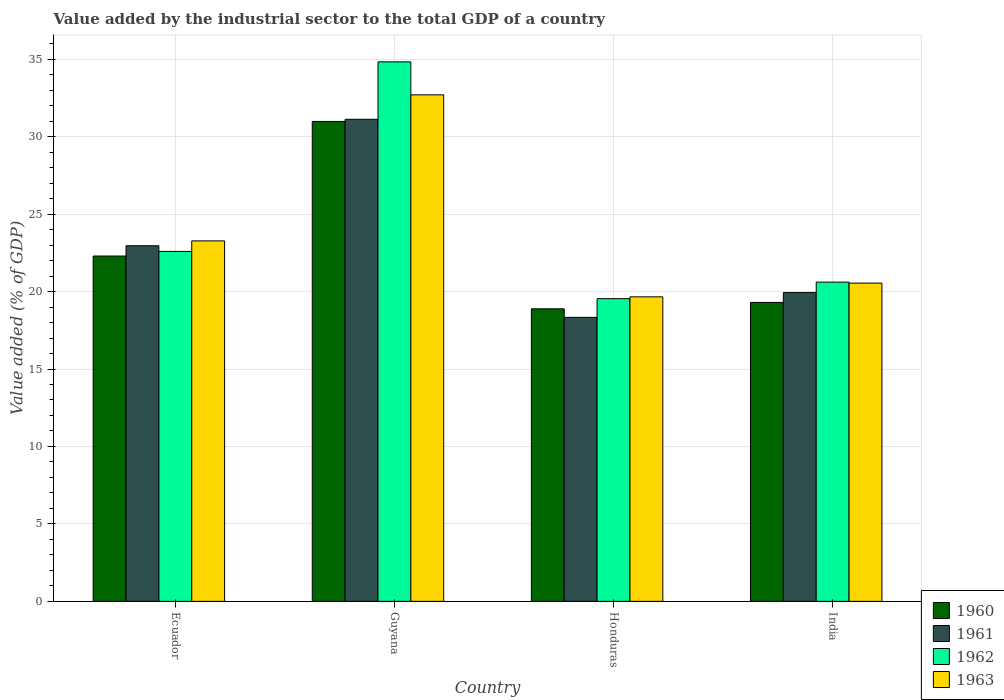How many different coloured bars are there?
Your answer should be very brief. 4. How many groups of bars are there?
Ensure brevity in your answer.  4. How many bars are there on the 3rd tick from the right?
Your answer should be compact. 4. What is the label of the 4th group of bars from the left?
Offer a very short reply. India. In how many cases, is the number of bars for a given country not equal to the number of legend labels?
Make the answer very short. 0. What is the value added by the industrial sector to the total GDP in 1963 in India?
Give a very brief answer. 20.54. Across all countries, what is the maximum value added by the industrial sector to the total GDP in 1960?
Provide a succinct answer. 30.98. Across all countries, what is the minimum value added by the industrial sector to the total GDP in 1961?
Provide a short and direct response. 18.33. In which country was the value added by the industrial sector to the total GDP in 1962 maximum?
Offer a very short reply. Guyana. In which country was the value added by the industrial sector to the total GDP in 1960 minimum?
Keep it short and to the point. Honduras. What is the total value added by the industrial sector to the total GDP in 1961 in the graph?
Your answer should be compact. 92.35. What is the difference between the value added by the industrial sector to the total GDP in 1962 in Ecuador and that in Guyana?
Provide a short and direct response. -12.24. What is the difference between the value added by the industrial sector to the total GDP in 1962 in India and the value added by the industrial sector to the total GDP in 1963 in Guyana?
Your answer should be very brief. -12.09. What is the average value added by the industrial sector to the total GDP in 1961 per country?
Provide a short and direct response. 23.09. What is the difference between the value added by the industrial sector to the total GDP of/in 1963 and value added by the industrial sector to the total GDP of/in 1962 in Guyana?
Provide a short and direct response. -2.13. In how many countries, is the value added by the industrial sector to the total GDP in 1962 greater than 31 %?
Offer a very short reply. 1. What is the ratio of the value added by the industrial sector to the total GDP in 1963 in Honduras to that in India?
Give a very brief answer. 0.96. Is the value added by the industrial sector to the total GDP in 1960 in Guyana less than that in India?
Your answer should be very brief. No. Is the difference between the value added by the industrial sector to the total GDP in 1963 in Guyana and India greater than the difference between the value added by the industrial sector to the total GDP in 1962 in Guyana and India?
Offer a very short reply. No. What is the difference between the highest and the second highest value added by the industrial sector to the total GDP in 1962?
Your answer should be very brief. 14.22. What is the difference between the highest and the lowest value added by the industrial sector to the total GDP in 1960?
Offer a terse response. 12.1. Is the sum of the value added by the industrial sector to the total GDP in 1962 in Ecuador and Honduras greater than the maximum value added by the industrial sector to the total GDP in 1963 across all countries?
Provide a short and direct response. Yes. What does the 1st bar from the right in Ecuador represents?
Provide a succinct answer. 1963. Is it the case that in every country, the sum of the value added by the industrial sector to the total GDP in 1960 and value added by the industrial sector to the total GDP in 1962 is greater than the value added by the industrial sector to the total GDP in 1961?
Keep it short and to the point. Yes. How many countries are there in the graph?
Your response must be concise. 4. What is the difference between two consecutive major ticks on the Y-axis?
Provide a short and direct response. 5. Are the values on the major ticks of Y-axis written in scientific E-notation?
Your answer should be very brief. No. Does the graph contain any zero values?
Your answer should be very brief. No. How many legend labels are there?
Provide a short and direct response. 4. What is the title of the graph?
Give a very brief answer. Value added by the industrial sector to the total GDP of a country. What is the label or title of the X-axis?
Keep it short and to the point. Country. What is the label or title of the Y-axis?
Keep it short and to the point. Value added (% of GDP). What is the Value added (% of GDP) of 1960 in Ecuador?
Ensure brevity in your answer.  22.29. What is the Value added (% of GDP) of 1961 in Ecuador?
Keep it short and to the point. 22.96. What is the Value added (% of GDP) of 1962 in Ecuador?
Provide a succinct answer. 22.59. What is the Value added (% of GDP) of 1963 in Ecuador?
Make the answer very short. 23.27. What is the Value added (% of GDP) of 1960 in Guyana?
Keep it short and to the point. 30.98. What is the Value added (% of GDP) in 1961 in Guyana?
Ensure brevity in your answer.  31.12. What is the Value added (% of GDP) in 1962 in Guyana?
Provide a succinct answer. 34.83. What is the Value added (% of GDP) of 1963 in Guyana?
Offer a terse response. 32.7. What is the Value added (% of GDP) of 1960 in Honduras?
Your answer should be compact. 18.89. What is the Value added (% of GDP) of 1961 in Honduras?
Provide a succinct answer. 18.33. What is the Value added (% of GDP) in 1962 in Honduras?
Your response must be concise. 19.54. What is the Value added (% of GDP) of 1963 in Honduras?
Your answer should be very brief. 19.66. What is the Value added (% of GDP) of 1960 in India?
Offer a very short reply. 19.3. What is the Value added (% of GDP) of 1961 in India?
Provide a succinct answer. 19.93. What is the Value added (% of GDP) in 1962 in India?
Your answer should be very brief. 20.61. What is the Value added (% of GDP) in 1963 in India?
Your answer should be compact. 20.54. Across all countries, what is the maximum Value added (% of GDP) of 1960?
Offer a very short reply. 30.98. Across all countries, what is the maximum Value added (% of GDP) of 1961?
Your response must be concise. 31.12. Across all countries, what is the maximum Value added (% of GDP) in 1962?
Your answer should be very brief. 34.83. Across all countries, what is the maximum Value added (% of GDP) of 1963?
Provide a short and direct response. 32.7. Across all countries, what is the minimum Value added (% of GDP) of 1960?
Make the answer very short. 18.89. Across all countries, what is the minimum Value added (% of GDP) in 1961?
Your answer should be very brief. 18.33. Across all countries, what is the minimum Value added (% of GDP) of 1962?
Ensure brevity in your answer.  19.54. Across all countries, what is the minimum Value added (% of GDP) of 1963?
Keep it short and to the point. 19.66. What is the total Value added (% of GDP) in 1960 in the graph?
Offer a terse response. 91.46. What is the total Value added (% of GDP) of 1961 in the graph?
Ensure brevity in your answer.  92.35. What is the total Value added (% of GDP) in 1962 in the graph?
Provide a short and direct response. 97.57. What is the total Value added (% of GDP) in 1963 in the graph?
Provide a succinct answer. 96.17. What is the difference between the Value added (% of GDP) of 1960 in Ecuador and that in Guyana?
Your answer should be very brief. -8.69. What is the difference between the Value added (% of GDP) of 1961 in Ecuador and that in Guyana?
Your response must be concise. -8.17. What is the difference between the Value added (% of GDP) of 1962 in Ecuador and that in Guyana?
Give a very brief answer. -12.24. What is the difference between the Value added (% of GDP) of 1963 in Ecuador and that in Guyana?
Give a very brief answer. -9.43. What is the difference between the Value added (% of GDP) in 1960 in Ecuador and that in Honduras?
Offer a very short reply. 3.41. What is the difference between the Value added (% of GDP) of 1961 in Ecuador and that in Honduras?
Provide a succinct answer. 4.62. What is the difference between the Value added (% of GDP) in 1962 in Ecuador and that in Honduras?
Your answer should be compact. 3.05. What is the difference between the Value added (% of GDP) of 1963 in Ecuador and that in Honduras?
Your answer should be compact. 3.61. What is the difference between the Value added (% of GDP) of 1960 in Ecuador and that in India?
Give a very brief answer. 2.99. What is the difference between the Value added (% of GDP) of 1961 in Ecuador and that in India?
Give a very brief answer. 3.02. What is the difference between the Value added (% of GDP) in 1962 in Ecuador and that in India?
Offer a terse response. 1.98. What is the difference between the Value added (% of GDP) of 1963 in Ecuador and that in India?
Offer a very short reply. 2.73. What is the difference between the Value added (% of GDP) of 1960 in Guyana and that in Honduras?
Offer a very short reply. 12.1. What is the difference between the Value added (% of GDP) of 1961 in Guyana and that in Honduras?
Your answer should be very brief. 12.79. What is the difference between the Value added (% of GDP) in 1962 in Guyana and that in Honduras?
Make the answer very short. 15.29. What is the difference between the Value added (% of GDP) of 1963 in Guyana and that in Honduras?
Your response must be concise. 13.04. What is the difference between the Value added (% of GDP) of 1960 in Guyana and that in India?
Give a very brief answer. 11.68. What is the difference between the Value added (% of GDP) of 1961 in Guyana and that in India?
Your answer should be compact. 11.19. What is the difference between the Value added (% of GDP) of 1962 in Guyana and that in India?
Make the answer very short. 14.22. What is the difference between the Value added (% of GDP) of 1963 in Guyana and that in India?
Keep it short and to the point. 12.15. What is the difference between the Value added (% of GDP) of 1960 in Honduras and that in India?
Provide a short and direct response. -0.41. What is the difference between the Value added (% of GDP) in 1961 in Honduras and that in India?
Offer a very short reply. -1.6. What is the difference between the Value added (% of GDP) of 1962 in Honduras and that in India?
Offer a terse response. -1.07. What is the difference between the Value added (% of GDP) in 1963 in Honduras and that in India?
Make the answer very short. -0.88. What is the difference between the Value added (% of GDP) in 1960 in Ecuador and the Value added (% of GDP) in 1961 in Guyana?
Make the answer very short. -8.83. What is the difference between the Value added (% of GDP) of 1960 in Ecuador and the Value added (% of GDP) of 1962 in Guyana?
Keep it short and to the point. -12.54. What is the difference between the Value added (% of GDP) in 1960 in Ecuador and the Value added (% of GDP) in 1963 in Guyana?
Offer a terse response. -10.4. What is the difference between the Value added (% of GDP) in 1961 in Ecuador and the Value added (% of GDP) in 1962 in Guyana?
Provide a short and direct response. -11.87. What is the difference between the Value added (% of GDP) of 1961 in Ecuador and the Value added (% of GDP) of 1963 in Guyana?
Give a very brief answer. -9.74. What is the difference between the Value added (% of GDP) in 1962 in Ecuador and the Value added (% of GDP) in 1963 in Guyana?
Offer a very short reply. -10.11. What is the difference between the Value added (% of GDP) of 1960 in Ecuador and the Value added (% of GDP) of 1961 in Honduras?
Give a very brief answer. 3.96. What is the difference between the Value added (% of GDP) in 1960 in Ecuador and the Value added (% of GDP) in 1962 in Honduras?
Your answer should be very brief. 2.75. What is the difference between the Value added (% of GDP) in 1960 in Ecuador and the Value added (% of GDP) in 1963 in Honduras?
Offer a very short reply. 2.64. What is the difference between the Value added (% of GDP) in 1961 in Ecuador and the Value added (% of GDP) in 1962 in Honduras?
Ensure brevity in your answer.  3.41. What is the difference between the Value added (% of GDP) of 1961 in Ecuador and the Value added (% of GDP) of 1963 in Honduras?
Ensure brevity in your answer.  3.3. What is the difference between the Value added (% of GDP) in 1962 in Ecuador and the Value added (% of GDP) in 1963 in Honduras?
Give a very brief answer. 2.93. What is the difference between the Value added (% of GDP) of 1960 in Ecuador and the Value added (% of GDP) of 1961 in India?
Offer a terse response. 2.36. What is the difference between the Value added (% of GDP) of 1960 in Ecuador and the Value added (% of GDP) of 1962 in India?
Your answer should be compact. 1.69. What is the difference between the Value added (% of GDP) of 1960 in Ecuador and the Value added (% of GDP) of 1963 in India?
Your answer should be compact. 1.75. What is the difference between the Value added (% of GDP) in 1961 in Ecuador and the Value added (% of GDP) in 1962 in India?
Make the answer very short. 2.35. What is the difference between the Value added (% of GDP) of 1961 in Ecuador and the Value added (% of GDP) of 1963 in India?
Offer a terse response. 2.41. What is the difference between the Value added (% of GDP) of 1962 in Ecuador and the Value added (% of GDP) of 1963 in India?
Keep it short and to the point. 2.05. What is the difference between the Value added (% of GDP) of 1960 in Guyana and the Value added (% of GDP) of 1961 in Honduras?
Make the answer very short. 12.65. What is the difference between the Value added (% of GDP) in 1960 in Guyana and the Value added (% of GDP) in 1962 in Honduras?
Keep it short and to the point. 11.44. What is the difference between the Value added (% of GDP) in 1960 in Guyana and the Value added (% of GDP) in 1963 in Honduras?
Offer a terse response. 11.32. What is the difference between the Value added (% of GDP) in 1961 in Guyana and the Value added (% of GDP) in 1962 in Honduras?
Provide a succinct answer. 11.58. What is the difference between the Value added (% of GDP) in 1961 in Guyana and the Value added (% of GDP) in 1963 in Honduras?
Your answer should be compact. 11.46. What is the difference between the Value added (% of GDP) of 1962 in Guyana and the Value added (% of GDP) of 1963 in Honduras?
Your response must be concise. 15.17. What is the difference between the Value added (% of GDP) of 1960 in Guyana and the Value added (% of GDP) of 1961 in India?
Your response must be concise. 11.05. What is the difference between the Value added (% of GDP) of 1960 in Guyana and the Value added (% of GDP) of 1962 in India?
Keep it short and to the point. 10.37. What is the difference between the Value added (% of GDP) in 1960 in Guyana and the Value added (% of GDP) in 1963 in India?
Offer a terse response. 10.44. What is the difference between the Value added (% of GDP) in 1961 in Guyana and the Value added (% of GDP) in 1962 in India?
Offer a very short reply. 10.51. What is the difference between the Value added (% of GDP) in 1961 in Guyana and the Value added (% of GDP) in 1963 in India?
Your response must be concise. 10.58. What is the difference between the Value added (% of GDP) in 1962 in Guyana and the Value added (% of GDP) in 1963 in India?
Your answer should be compact. 14.29. What is the difference between the Value added (% of GDP) in 1960 in Honduras and the Value added (% of GDP) in 1961 in India?
Provide a succinct answer. -1.05. What is the difference between the Value added (% of GDP) of 1960 in Honduras and the Value added (% of GDP) of 1962 in India?
Make the answer very short. -1.72. What is the difference between the Value added (% of GDP) of 1960 in Honduras and the Value added (% of GDP) of 1963 in India?
Offer a terse response. -1.66. What is the difference between the Value added (% of GDP) of 1961 in Honduras and the Value added (% of GDP) of 1962 in India?
Provide a short and direct response. -2.27. What is the difference between the Value added (% of GDP) of 1961 in Honduras and the Value added (% of GDP) of 1963 in India?
Offer a very short reply. -2.21. What is the difference between the Value added (% of GDP) in 1962 in Honduras and the Value added (% of GDP) in 1963 in India?
Give a very brief answer. -1. What is the average Value added (% of GDP) in 1960 per country?
Your response must be concise. 22.87. What is the average Value added (% of GDP) in 1961 per country?
Provide a short and direct response. 23.09. What is the average Value added (% of GDP) of 1962 per country?
Give a very brief answer. 24.39. What is the average Value added (% of GDP) of 1963 per country?
Provide a succinct answer. 24.04. What is the difference between the Value added (% of GDP) in 1960 and Value added (% of GDP) in 1961 in Ecuador?
Your response must be concise. -0.66. What is the difference between the Value added (% of GDP) in 1960 and Value added (% of GDP) in 1962 in Ecuador?
Provide a succinct answer. -0.3. What is the difference between the Value added (% of GDP) of 1960 and Value added (% of GDP) of 1963 in Ecuador?
Provide a succinct answer. -0.98. What is the difference between the Value added (% of GDP) of 1961 and Value added (% of GDP) of 1962 in Ecuador?
Offer a terse response. 0.36. What is the difference between the Value added (% of GDP) in 1961 and Value added (% of GDP) in 1963 in Ecuador?
Provide a succinct answer. -0.31. What is the difference between the Value added (% of GDP) of 1962 and Value added (% of GDP) of 1963 in Ecuador?
Your response must be concise. -0.68. What is the difference between the Value added (% of GDP) of 1960 and Value added (% of GDP) of 1961 in Guyana?
Ensure brevity in your answer.  -0.14. What is the difference between the Value added (% of GDP) of 1960 and Value added (% of GDP) of 1962 in Guyana?
Provide a succinct answer. -3.85. What is the difference between the Value added (% of GDP) of 1960 and Value added (% of GDP) of 1963 in Guyana?
Provide a short and direct response. -1.72. What is the difference between the Value added (% of GDP) of 1961 and Value added (% of GDP) of 1962 in Guyana?
Provide a short and direct response. -3.71. What is the difference between the Value added (% of GDP) in 1961 and Value added (% of GDP) in 1963 in Guyana?
Keep it short and to the point. -1.58. What is the difference between the Value added (% of GDP) of 1962 and Value added (% of GDP) of 1963 in Guyana?
Make the answer very short. 2.13. What is the difference between the Value added (% of GDP) in 1960 and Value added (% of GDP) in 1961 in Honduras?
Offer a terse response. 0.55. What is the difference between the Value added (% of GDP) of 1960 and Value added (% of GDP) of 1962 in Honduras?
Make the answer very short. -0.66. What is the difference between the Value added (% of GDP) of 1960 and Value added (% of GDP) of 1963 in Honduras?
Ensure brevity in your answer.  -0.77. What is the difference between the Value added (% of GDP) in 1961 and Value added (% of GDP) in 1962 in Honduras?
Give a very brief answer. -1.21. What is the difference between the Value added (% of GDP) in 1961 and Value added (% of GDP) in 1963 in Honduras?
Your answer should be compact. -1.32. What is the difference between the Value added (% of GDP) of 1962 and Value added (% of GDP) of 1963 in Honduras?
Ensure brevity in your answer.  -0.12. What is the difference between the Value added (% of GDP) in 1960 and Value added (% of GDP) in 1961 in India?
Keep it short and to the point. -0.63. What is the difference between the Value added (% of GDP) of 1960 and Value added (% of GDP) of 1962 in India?
Make the answer very short. -1.31. What is the difference between the Value added (% of GDP) in 1960 and Value added (% of GDP) in 1963 in India?
Your response must be concise. -1.24. What is the difference between the Value added (% of GDP) of 1961 and Value added (% of GDP) of 1962 in India?
Keep it short and to the point. -0.68. What is the difference between the Value added (% of GDP) in 1961 and Value added (% of GDP) in 1963 in India?
Keep it short and to the point. -0.61. What is the difference between the Value added (% of GDP) in 1962 and Value added (% of GDP) in 1963 in India?
Your answer should be very brief. 0.06. What is the ratio of the Value added (% of GDP) in 1960 in Ecuador to that in Guyana?
Make the answer very short. 0.72. What is the ratio of the Value added (% of GDP) in 1961 in Ecuador to that in Guyana?
Your answer should be compact. 0.74. What is the ratio of the Value added (% of GDP) of 1962 in Ecuador to that in Guyana?
Your answer should be very brief. 0.65. What is the ratio of the Value added (% of GDP) in 1963 in Ecuador to that in Guyana?
Your response must be concise. 0.71. What is the ratio of the Value added (% of GDP) in 1960 in Ecuador to that in Honduras?
Give a very brief answer. 1.18. What is the ratio of the Value added (% of GDP) in 1961 in Ecuador to that in Honduras?
Your response must be concise. 1.25. What is the ratio of the Value added (% of GDP) of 1962 in Ecuador to that in Honduras?
Give a very brief answer. 1.16. What is the ratio of the Value added (% of GDP) in 1963 in Ecuador to that in Honduras?
Offer a terse response. 1.18. What is the ratio of the Value added (% of GDP) of 1960 in Ecuador to that in India?
Your answer should be very brief. 1.16. What is the ratio of the Value added (% of GDP) of 1961 in Ecuador to that in India?
Keep it short and to the point. 1.15. What is the ratio of the Value added (% of GDP) of 1962 in Ecuador to that in India?
Offer a terse response. 1.1. What is the ratio of the Value added (% of GDP) in 1963 in Ecuador to that in India?
Offer a very short reply. 1.13. What is the ratio of the Value added (% of GDP) in 1960 in Guyana to that in Honduras?
Offer a very short reply. 1.64. What is the ratio of the Value added (% of GDP) of 1961 in Guyana to that in Honduras?
Your answer should be very brief. 1.7. What is the ratio of the Value added (% of GDP) in 1962 in Guyana to that in Honduras?
Give a very brief answer. 1.78. What is the ratio of the Value added (% of GDP) in 1963 in Guyana to that in Honduras?
Keep it short and to the point. 1.66. What is the ratio of the Value added (% of GDP) in 1960 in Guyana to that in India?
Your answer should be very brief. 1.61. What is the ratio of the Value added (% of GDP) of 1961 in Guyana to that in India?
Offer a terse response. 1.56. What is the ratio of the Value added (% of GDP) in 1962 in Guyana to that in India?
Provide a short and direct response. 1.69. What is the ratio of the Value added (% of GDP) in 1963 in Guyana to that in India?
Make the answer very short. 1.59. What is the ratio of the Value added (% of GDP) in 1960 in Honduras to that in India?
Offer a very short reply. 0.98. What is the ratio of the Value added (% of GDP) of 1961 in Honduras to that in India?
Offer a terse response. 0.92. What is the ratio of the Value added (% of GDP) of 1962 in Honduras to that in India?
Make the answer very short. 0.95. What is the ratio of the Value added (% of GDP) in 1963 in Honduras to that in India?
Give a very brief answer. 0.96. What is the difference between the highest and the second highest Value added (% of GDP) in 1960?
Offer a very short reply. 8.69. What is the difference between the highest and the second highest Value added (% of GDP) in 1961?
Ensure brevity in your answer.  8.17. What is the difference between the highest and the second highest Value added (% of GDP) in 1962?
Give a very brief answer. 12.24. What is the difference between the highest and the second highest Value added (% of GDP) in 1963?
Your answer should be very brief. 9.43. What is the difference between the highest and the lowest Value added (% of GDP) in 1960?
Make the answer very short. 12.1. What is the difference between the highest and the lowest Value added (% of GDP) in 1961?
Offer a very short reply. 12.79. What is the difference between the highest and the lowest Value added (% of GDP) in 1962?
Keep it short and to the point. 15.29. What is the difference between the highest and the lowest Value added (% of GDP) in 1963?
Provide a succinct answer. 13.04. 